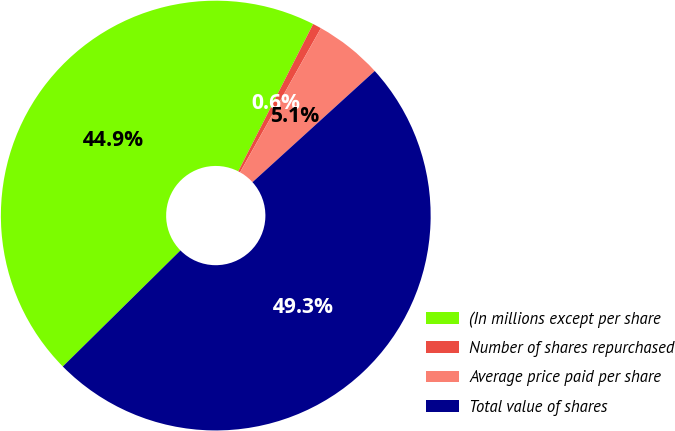Convert chart. <chart><loc_0><loc_0><loc_500><loc_500><pie_chart><fcel>(In millions except per share<fcel>Number of shares repurchased<fcel>Average price paid per share<fcel>Total value of shares<nl><fcel>44.88%<fcel>0.65%<fcel>5.12%<fcel>49.35%<nl></chart> 